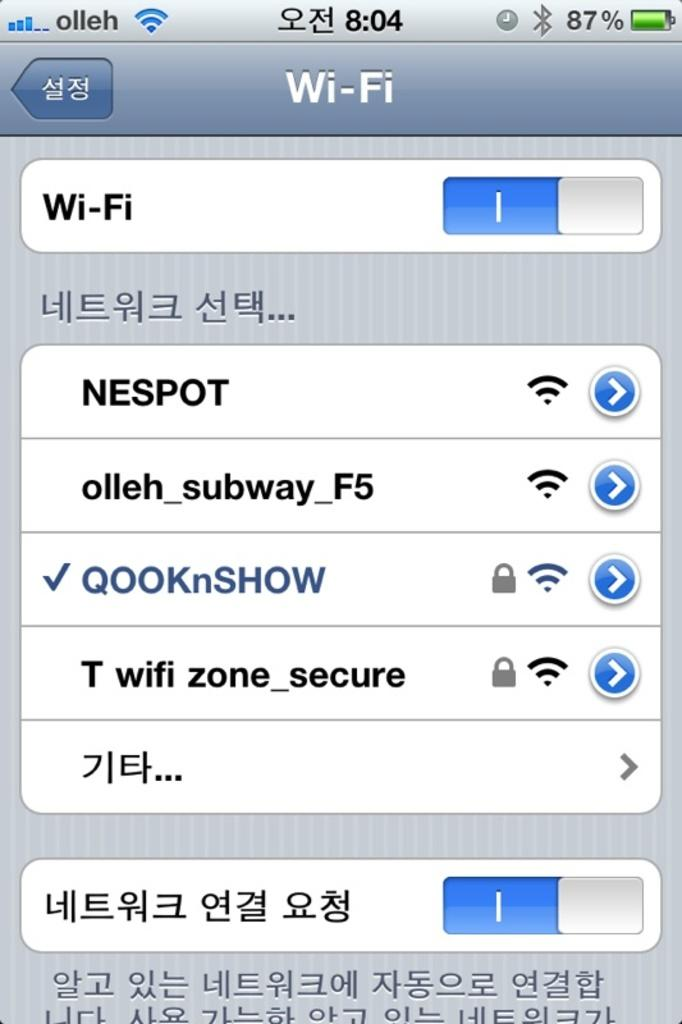<image>
Offer a succinct explanation of the picture presented. A screen for Wi-Fi settings shows the device is connected to the QOOKnSHOW wifi 